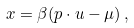<formula> <loc_0><loc_0><loc_500><loc_500>x = \beta ( p \cdot u - \mu ) \, ,</formula> 